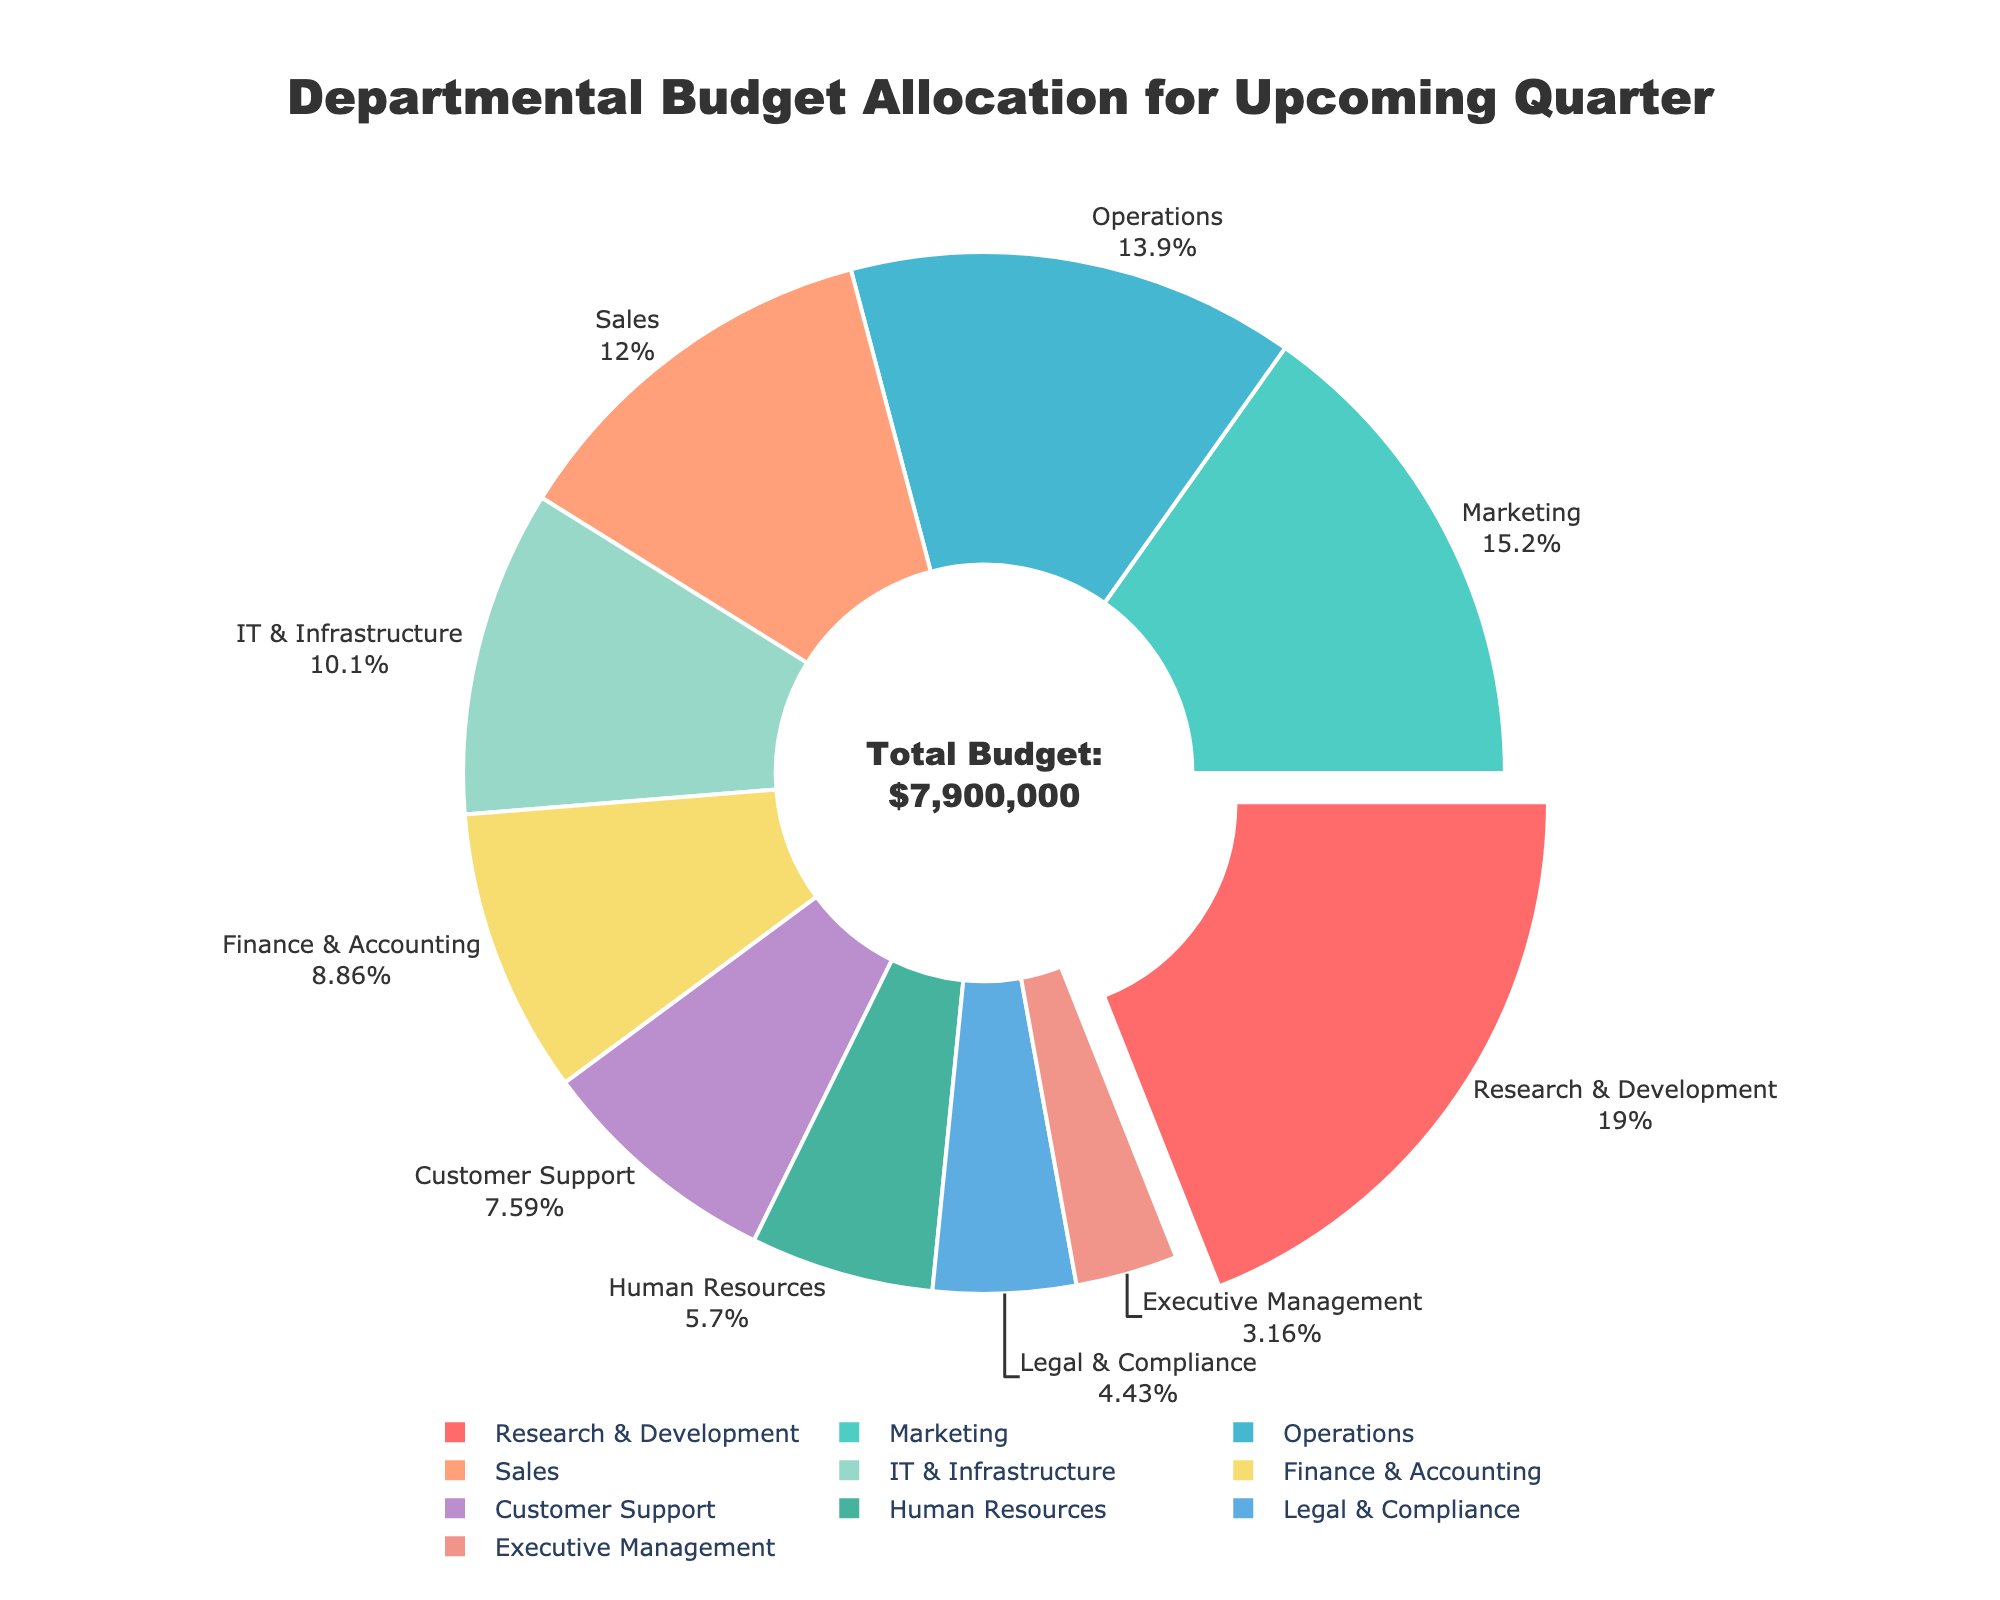Which department has the largest budget allocation and what percentage is it? The Research & Development department has the largest budget allocation, which can be seen as it is the largest segment in the pie chart and is also the one pulled out slightly for emphasis. The percentage shown next to it confirms this.
Answer: Research & Development, 21.3% How does the budget for Marketing compare to Sales? By visually comparing the sizes of the segments and the percentage labels, it can be seen that the Marketing budget is slightly larger than that of Sales. Marketing's segment is a bit bigger and has a percentage of 17.0% compared to 13.4% for Sales.
Answer: Marketing is larger by 3.6% What is the combined budget allocation for IT & Infrastructure and Finance & Accounting? Sum the percentages for these two departments: IT & Infrastructure (11.3%) and Finance & Accounting (9.1%).
Answer: 20.4% Which departments have a budget allocation of less than 10%? From the pie chart, segments with labels and percentages less than 10% are for Legal & Compliance (5.0%), Executive Management (3.6%), Customer Support (8.5%), and Human Resources (6.4%).
Answer: Legal & Compliance, Executive Management, Customer Support, Human Resources What is the difference in budget allocation between Operations and Human Resources? Subtract the percentage of Human Resources (6.4%) from the percentage of Operations (15.6%).
Answer: 9.2% How many departments have a budget allocation greater than 15%? Based on the pie chart, Research & Development (21.3%) and Marketing (17.0%) are the departments with allocations greater than 15%.
Answer: Two If the total budget is $7,800,000, calculate the budget allocation for Customer Support. The percentage allocation for Customer Support is 8.5%. Calculate 8.5% of $7,800,000: 0.085 * 7,800,000 = $663,000.
Answer: $663,000 Which segment is colored red and what department does it represent? Visually identify the red segment in the chart, which is the largest pulled-out piece representing the Research & Development department.
Answer: Research & Development What is the budget allocation for the smallest department by percentage, and which department is it? The smallest segment in the pie chart represents Executive Management with a budget allocation of 3.6%.
Answer: Executive Management, 3.6% What is the percentage difference between the largest and smallest budget allocations? Subtract the percentage of Executive Management (3.6%) from the percentage of Research & Development (21.3%).
Answer: 17.7% 